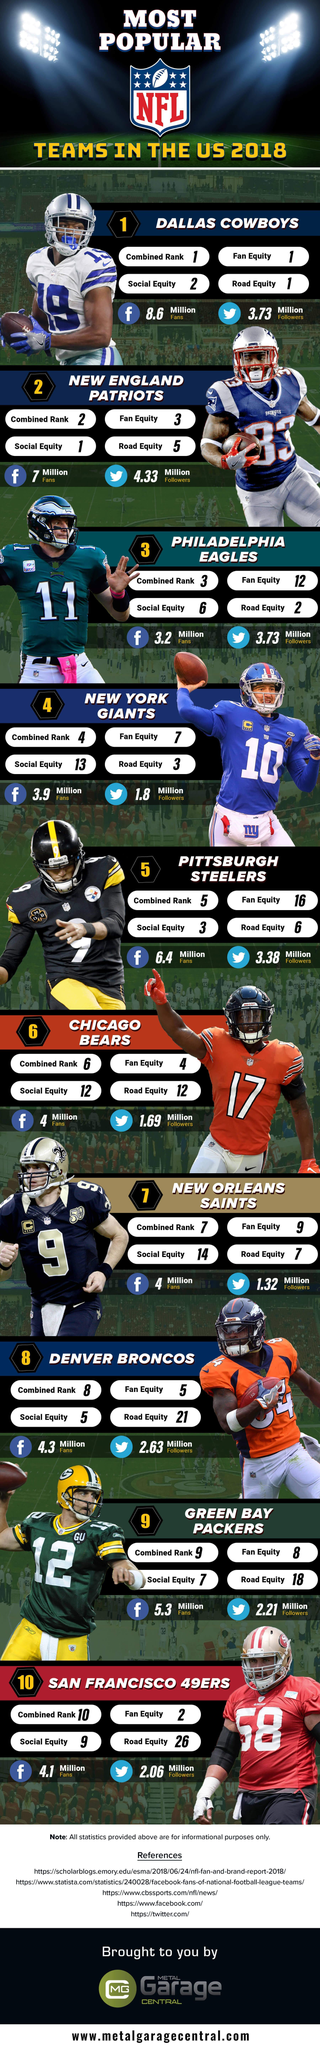Which NFL Team has the top social equity ranking among the most popular teams in the US in 2018?
Answer the question with a short phrase. NEW ENGLAND PATRIOTS Which NFL Team has the lowest road equity ranking among the most popular teams in the US in 2018? SAN FRANCISCO 49ERS Which NFL Team has the top fan equity ranking among the most popular teams in the US in 2018? DALLAS COWBOYS What is the number of facebook followers of New York Giants in the US in 2018? 3.9 Million How many Twitter followers are there for Dallas Cowboys in the US in 2018? 3.73 Million Which NFL Team has the lowest social equity ranking among the most popular teams in the US in 2018? NEW ORLEANS SAINTS What is the jersey number of New York Giants player shown here? 10 What colour jersey do 'Chicago Bears' wear - Blue, Green, Orange, Black? Orange Which NFL team has the most Twitter followers among the most popular teams in the US in 2018? NEW ENGLAND PATRIOTS What is the jersey number of 'Green Bay Packers' player shown here? 12 